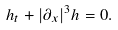Convert formula to latex. <formula><loc_0><loc_0><loc_500><loc_500>h _ { t } + | \partial _ { x } | ^ { 3 } h = 0 .</formula> 